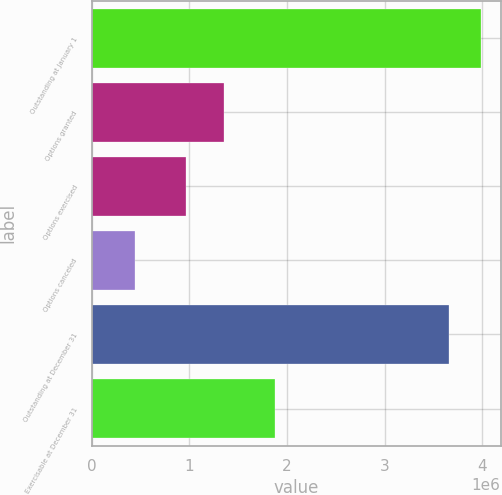Convert chart. <chart><loc_0><loc_0><loc_500><loc_500><bar_chart><fcel>Outstanding at January 1<fcel>Options granted<fcel>Options exercised<fcel>Options canceled<fcel>Outstanding at December 31<fcel>Exercisable at December 31<nl><fcel>3.98969e+06<fcel>1.3508e+06<fcel>967945<fcel>446493<fcel>3.6618e+06<fcel>1.87426e+06<nl></chart> 